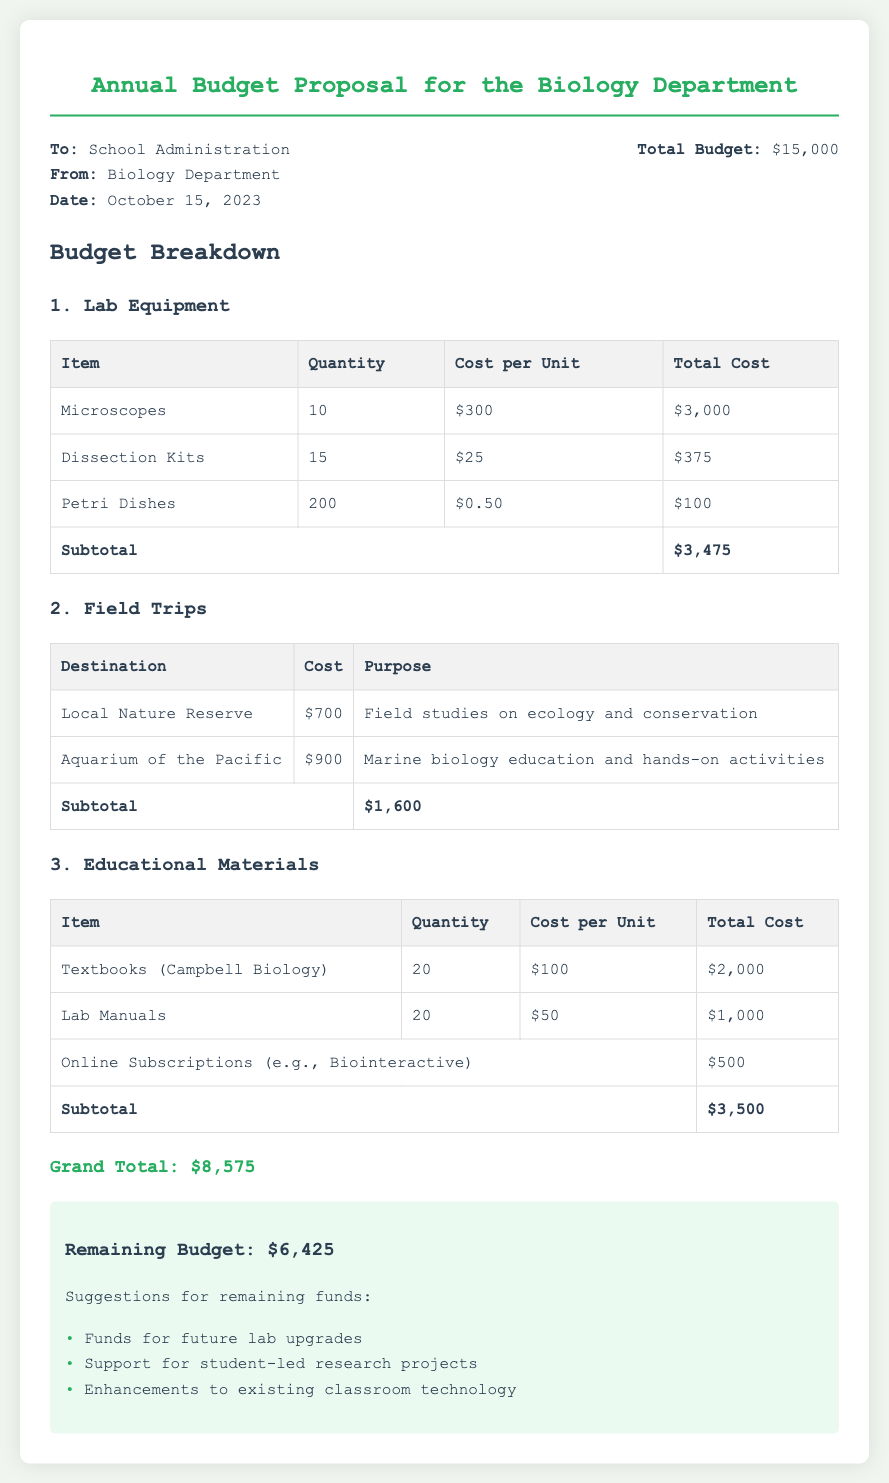What is the total budget for the Biology Department? The total budget stated in the memo is $15,000.
Answer: $15,000 How many microscopes are proposed for purchase? The document lists the purchase of 10 microscopes.
Answer: 10 What is the total cost for the dissection kits? The total cost for the dissection kits is calculated as $25 per unit times 15 units, totaling $375.
Answer: $375 What is the purpose of the field trip to the Local Nature Reserve? The purpose of the field trip to the Local Nature Reserve is for field studies on ecology and conservation.
Answer: Field studies on ecology and conservation What is the subtotal for lab equipment? The subtotal for lab equipment, as detailed in the document, is $3,475.
Answer: $3,475 What is the grand total of all proposed expenditures? The grand total of all proposed expenditures is provided as $8,575.
Answer: $8,575 How much money remains in the budget after proposed expenditures? The remaining budget after all proposed expenditures is $6,425.
Answer: $6,425 What suggestion is made for the remaining budget? One of the suggestions made for the remaining budget is to support student-led research projects.
Answer: Support for student-led research projects What is the cost per unit of textbooks (Campbell Biology)? The cost per unit of textbooks (Campbell Biology) is stated as $100.
Answer: $100 